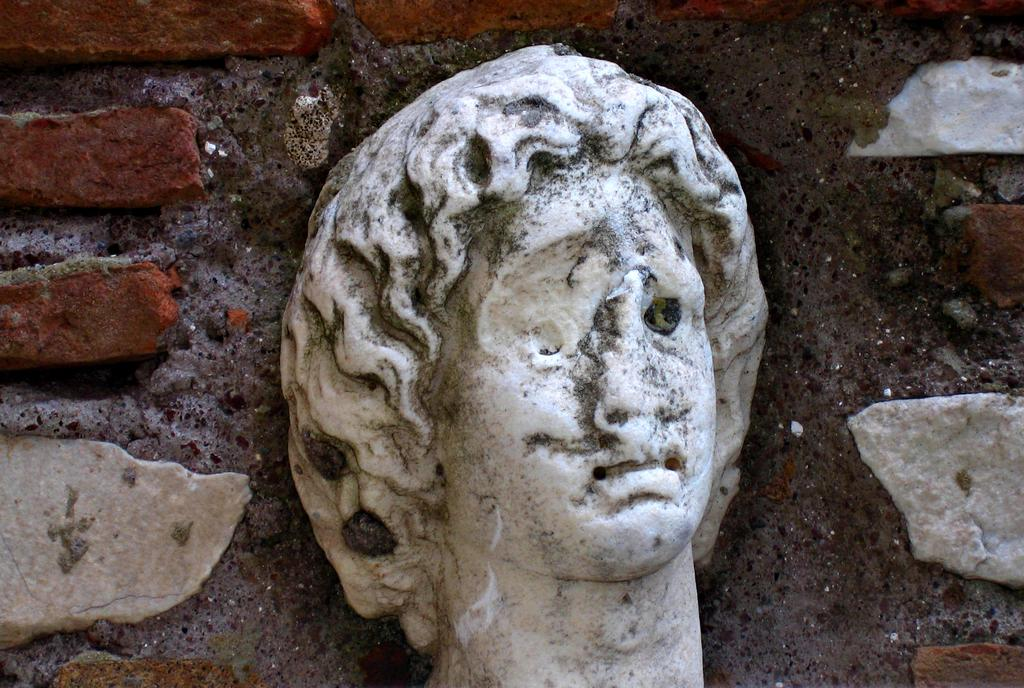What is the main subject of the image? The main subject of the image is a damaged statue. How is the statue damaged? The statue's face is damaged. What can be seen around the statue? There are bricks around the statue. Can you see an ant crawling on the damaged statue in the image? There is no ant present in the image; it only features a damaged statue and bricks. 